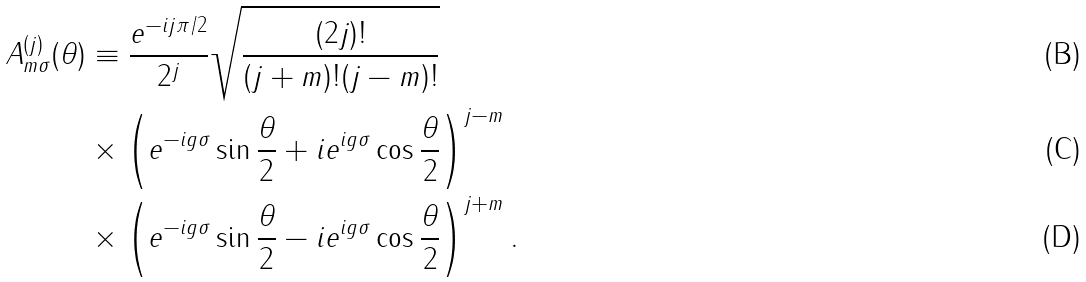<formula> <loc_0><loc_0><loc_500><loc_500>A _ { m \sigma } ^ { ( j ) } ( \theta ) & \equiv \frac { e ^ { - i j \pi / 2 } } { 2 ^ { j } } \sqrt { \frac { ( 2 j ) ! } { ( j + m ) ! ( j - m ) ! } } \\ & \times \left ( e ^ { - i g \sigma } \sin \frac { \theta } { 2 } + i e ^ { i g \sigma } \cos \frac { \theta } { 2 } \right ) ^ { j - m } \\ & \times \left ( e ^ { - i g \sigma } \sin \frac { \theta } { 2 } - i e ^ { i g \sigma } \cos \frac { \theta } { 2 } \right ) ^ { j + m } .</formula> 